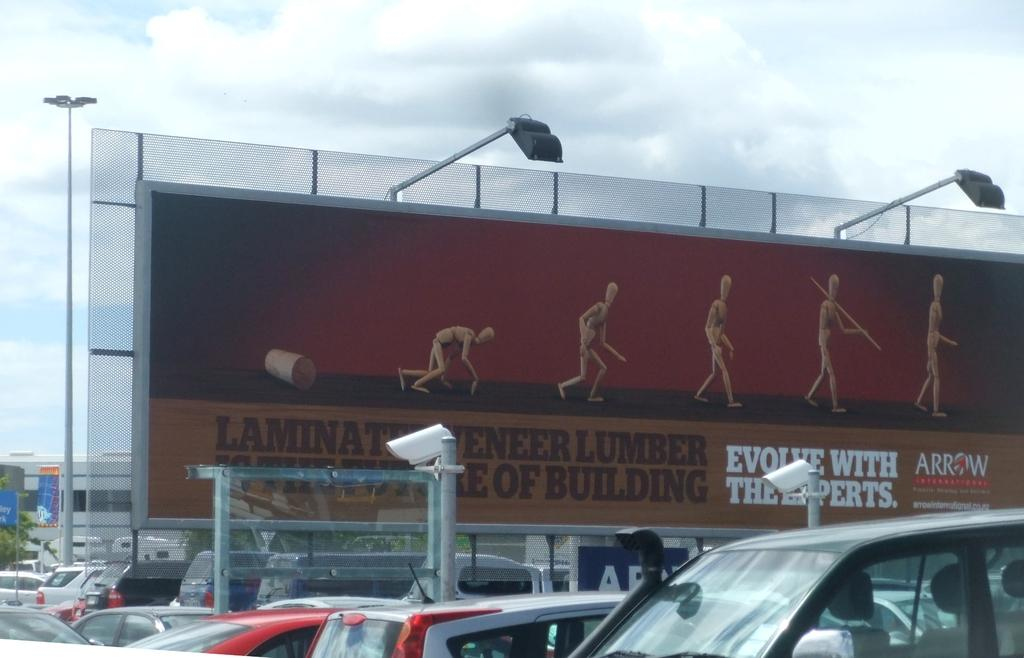<image>
Describe the image concisely. A billboard for Arrow International displays a wooden figure in different phases of rising and walking. 